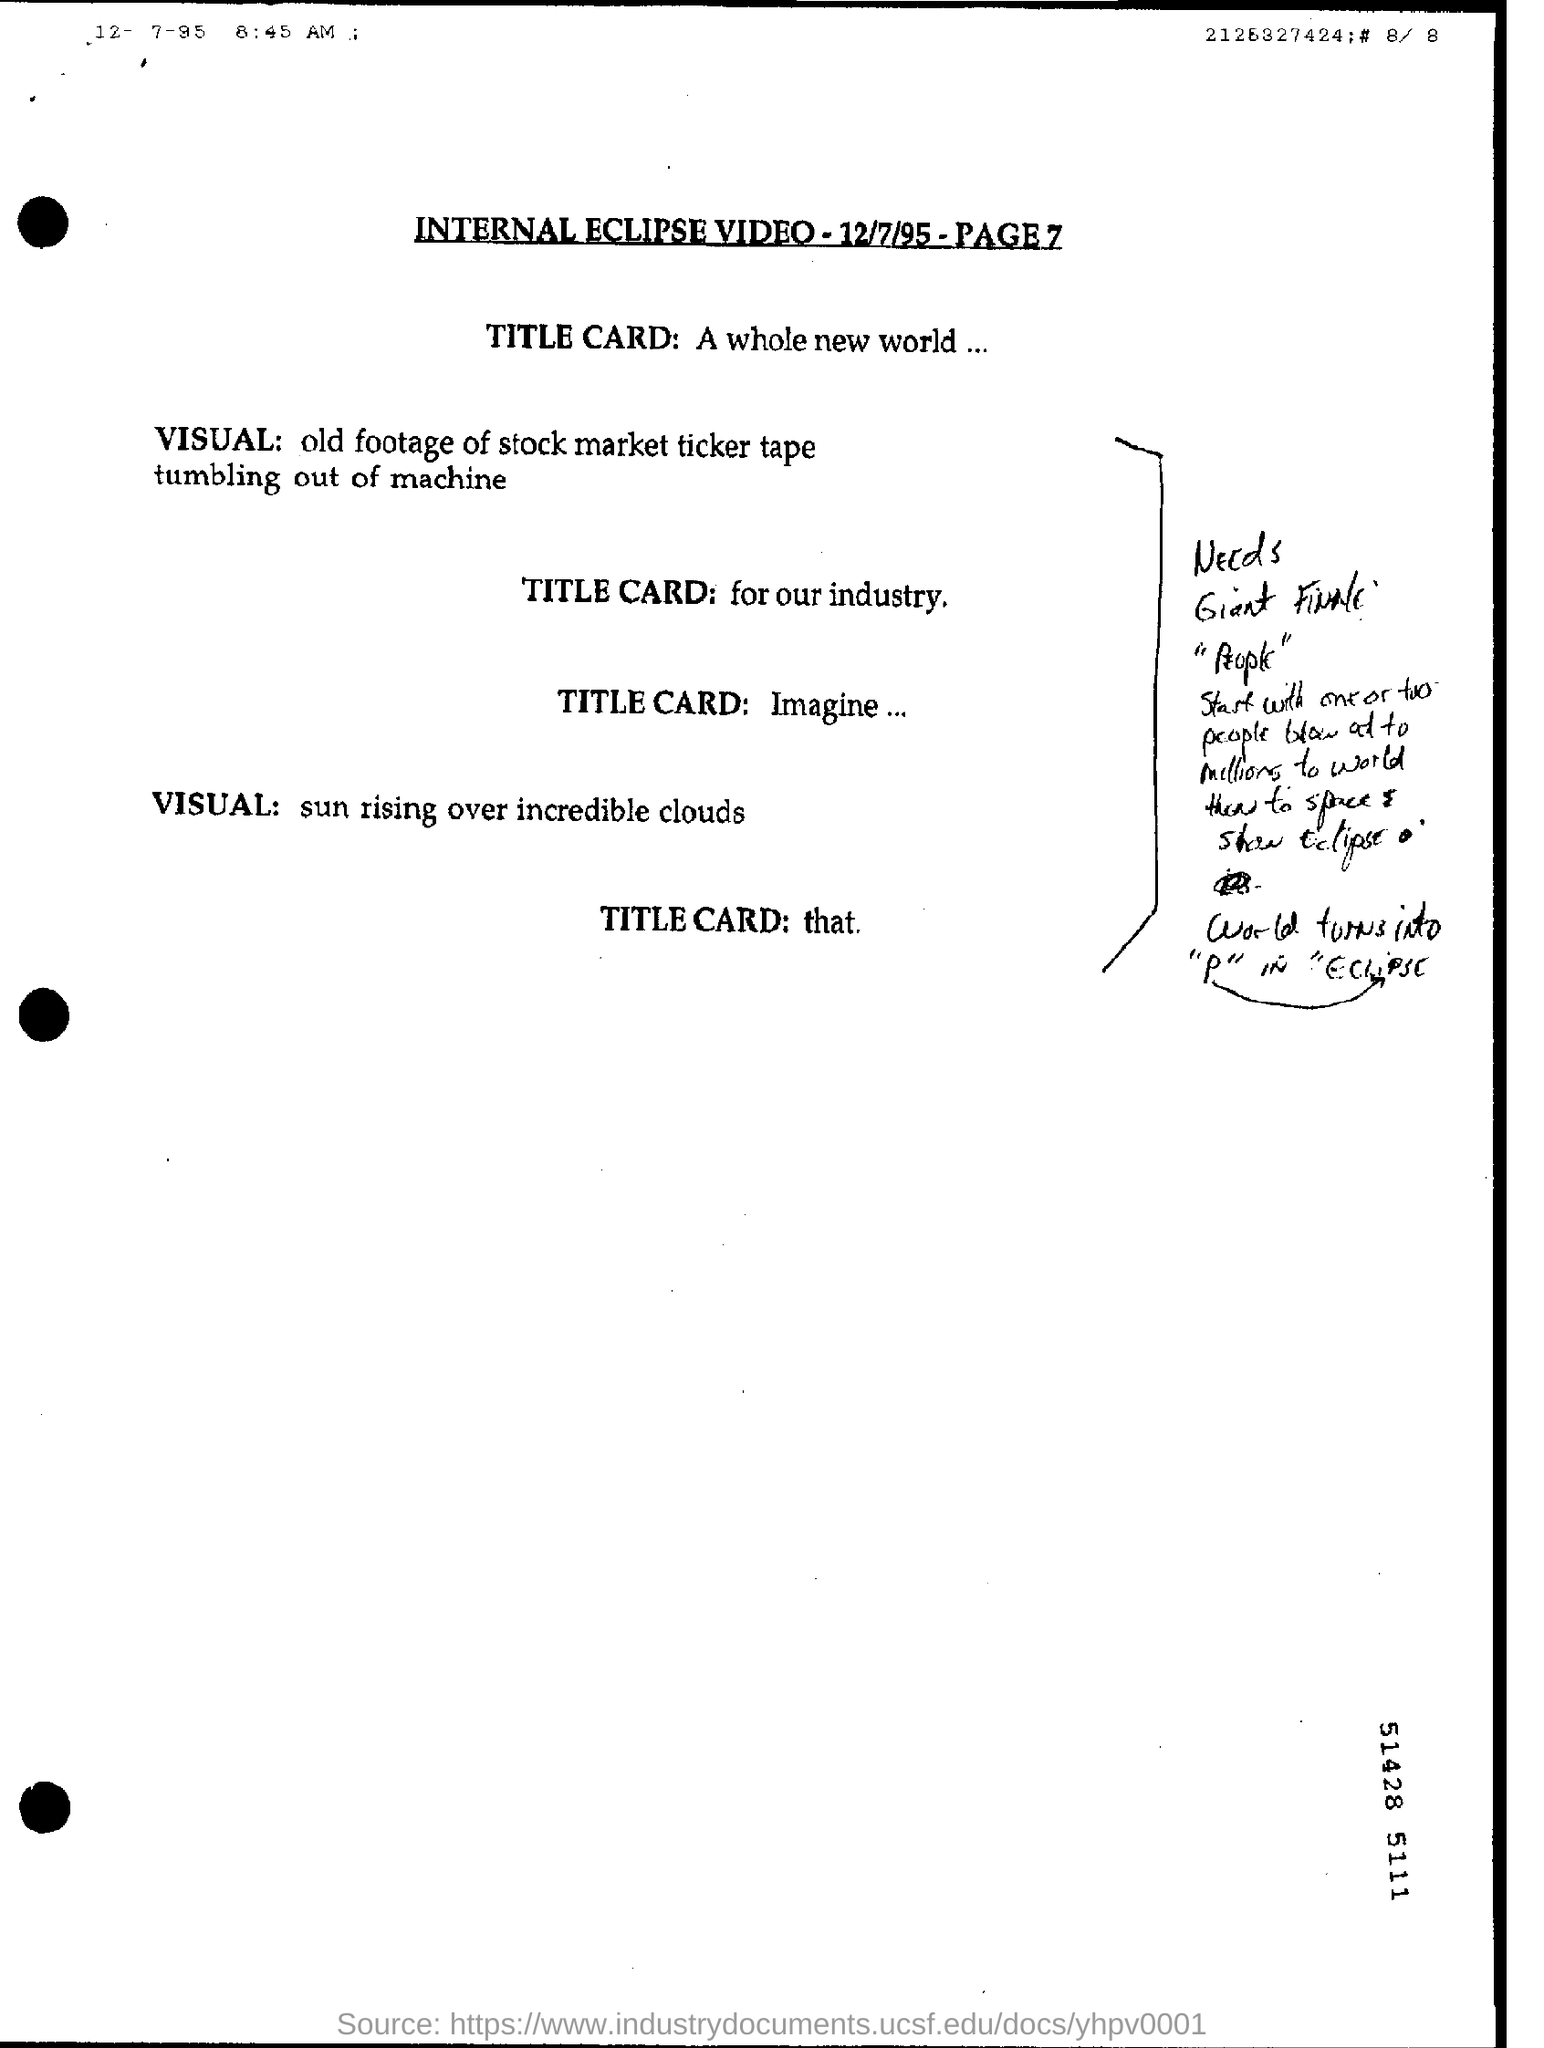What was the video about?
Make the answer very short. INTERNAL ECLIPSE. How many number of people where blow at to millions?
Provide a short and direct response. One or two. What does the word finally turn into as per the script?
Your answer should be very brief. "P" IN "ECLIPSE. How many people blow out to millions?
Provide a succinct answer. One or two. What was the second VISUAL?
Provide a succinct answer. Sun rising over incredible clouds. 